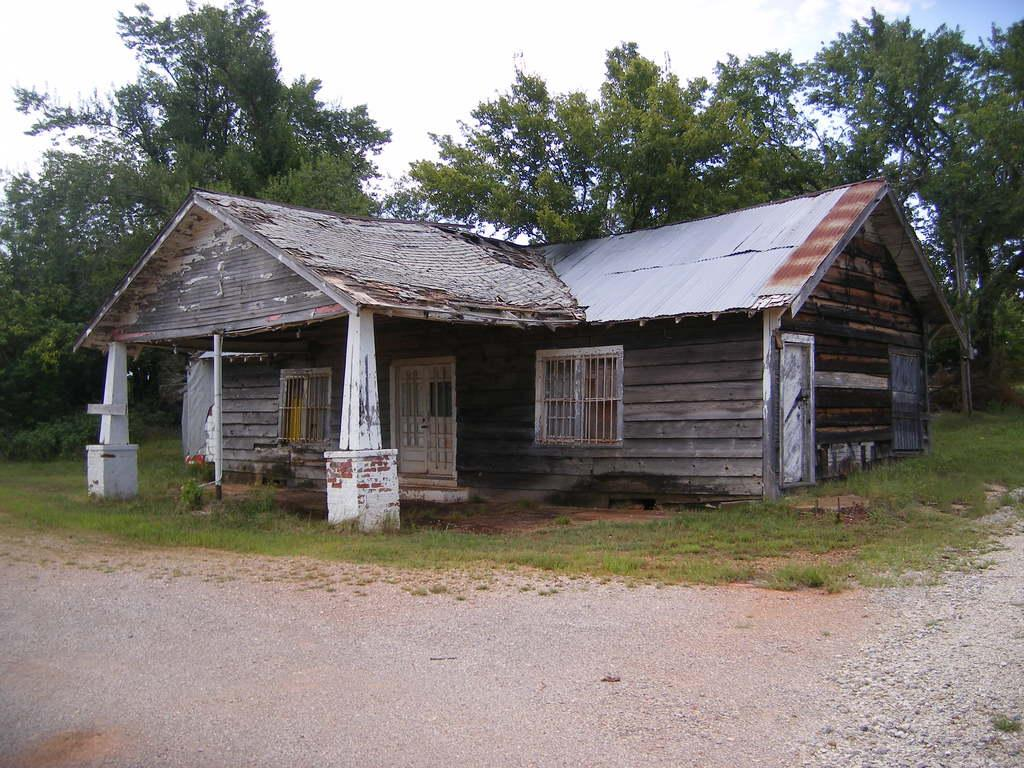What type of structure is present in the image? There is a house in the image. Where is the house situated? The house is located on a path. What can be seen behind the house? There are trees visible behind the house. What is visible in the sky in the image? The sky is visible in the image. Can you see the crown on the king's head in the image? There is no king or crown present in the image; it features a house on a path with trees and the sky visible. 